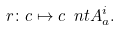<formula> <loc_0><loc_0><loc_500><loc_500>r \colon c \mapsto c \ n t { A } ^ { i } _ { a } .</formula> 